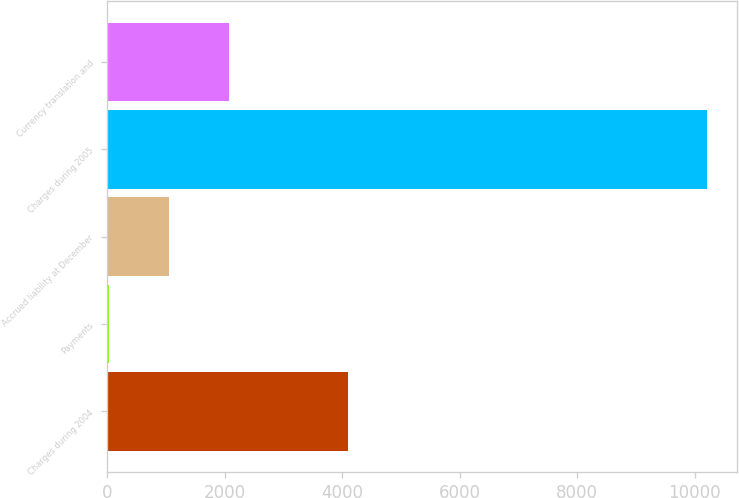Convert chart to OTSL. <chart><loc_0><loc_0><loc_500><loc_500><bar_chart><fcel>Charges during 2004<fcel>Payments<fcel>Accrued liability at December<fcel>Charges during 2005<fcel>Currency translation and<nl><fcel>4103<fcel>35<fcel>1052<fcel>10205<fcel>2069<nl></chart> 